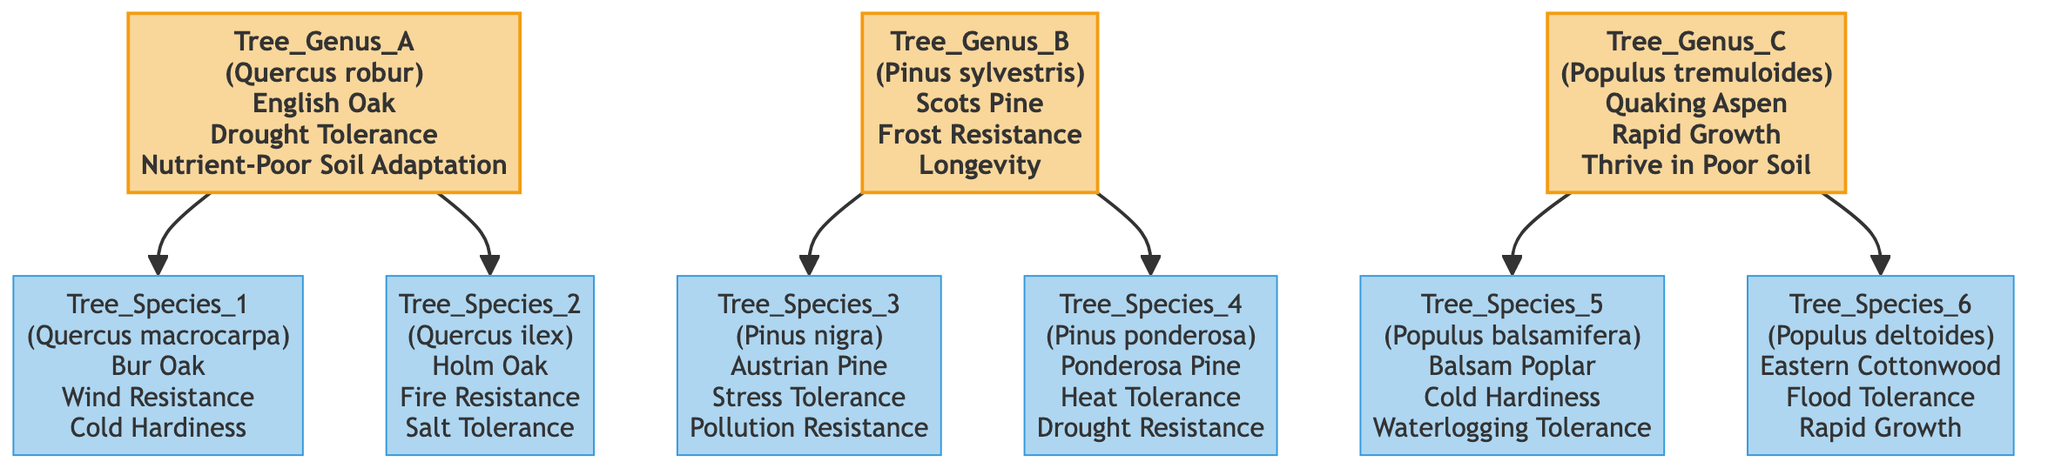What is the common name of Tree Genus A? Tree Genus A corresponds to Quercus robur, which has the common name English Oak. This information is displayed directly in the node for Tree Genus A.
Answer: English Oak How many tree species are descendants of Tree Genus B? Tree Genus B has two descendants listed under it: Pinus nigra and Pinus ponderosa. Therefore, the count of tree species is determined by counting the descendant nodes.
Answer: 2 What trait is shared between Quercus ilex and Quercus macrocarpa? To find a shared trait, we compare the traits of Quercus ilex (Fire Resistance, Salt Tolerance) and Quercus macrocarpa (Wind Resistance, Cold Hardiness). Neither trait overlaps, indicating no shared characteristics.
Answer: None Which tree species is known for its flood tolerance? The traits of the descendants of Tree Genus C (Populus tremuloides) include the Eastern Cottonwood, specifically noted for its flood tolerance trait. We obtain this from the description of Tree Species 6 (Populus deltoides).
Answer: Eastern Cottonwood What is the primary trait of Tree Genus C? The primary traits of Tree Genus C (Populus tremuloides) include Rapid Growth and Thrive in Poor Soil. The question asks for one primary trait, which is simply retrieved from the information in the node.
Answer: Rapid Growth Which tree species has a trait of pollution resistance? Looking at Tree Species 3 (Austrian Pine), it is noted for having the trait of Pollution Resistance. This information is clearly presented in the node for Tree Species 3.
Answer: Pinus nigra Identify the genus that exhibits heat tolerance. By examining the descendants of Tree Genus B (Pinus sylvestris), we find Pinus ponderosa, which is specifically recognized for its Heat Tolerance trait. Thus, we trace back to provide the genus associated with this species.
Answer: Tree Genus B How many total genera are displayed in the family tree? The family tree comprises three distinct tree genera: Tree Genus A, Tree Genus B, and Tree Genus C. This total is determined by counting the main nodes at the top level of the diagram.
Answer: 3 What unique characteristic is associated with Populus balsamifera? Populus balsamifera (Balsam Poplar) possesses the unique traits of Cold Hardiness and Waterlogging Tolerance, as indicated beneath its node. To answer, we can directly reference the provided information in the diagram.
Answer: Cold Hardiness 